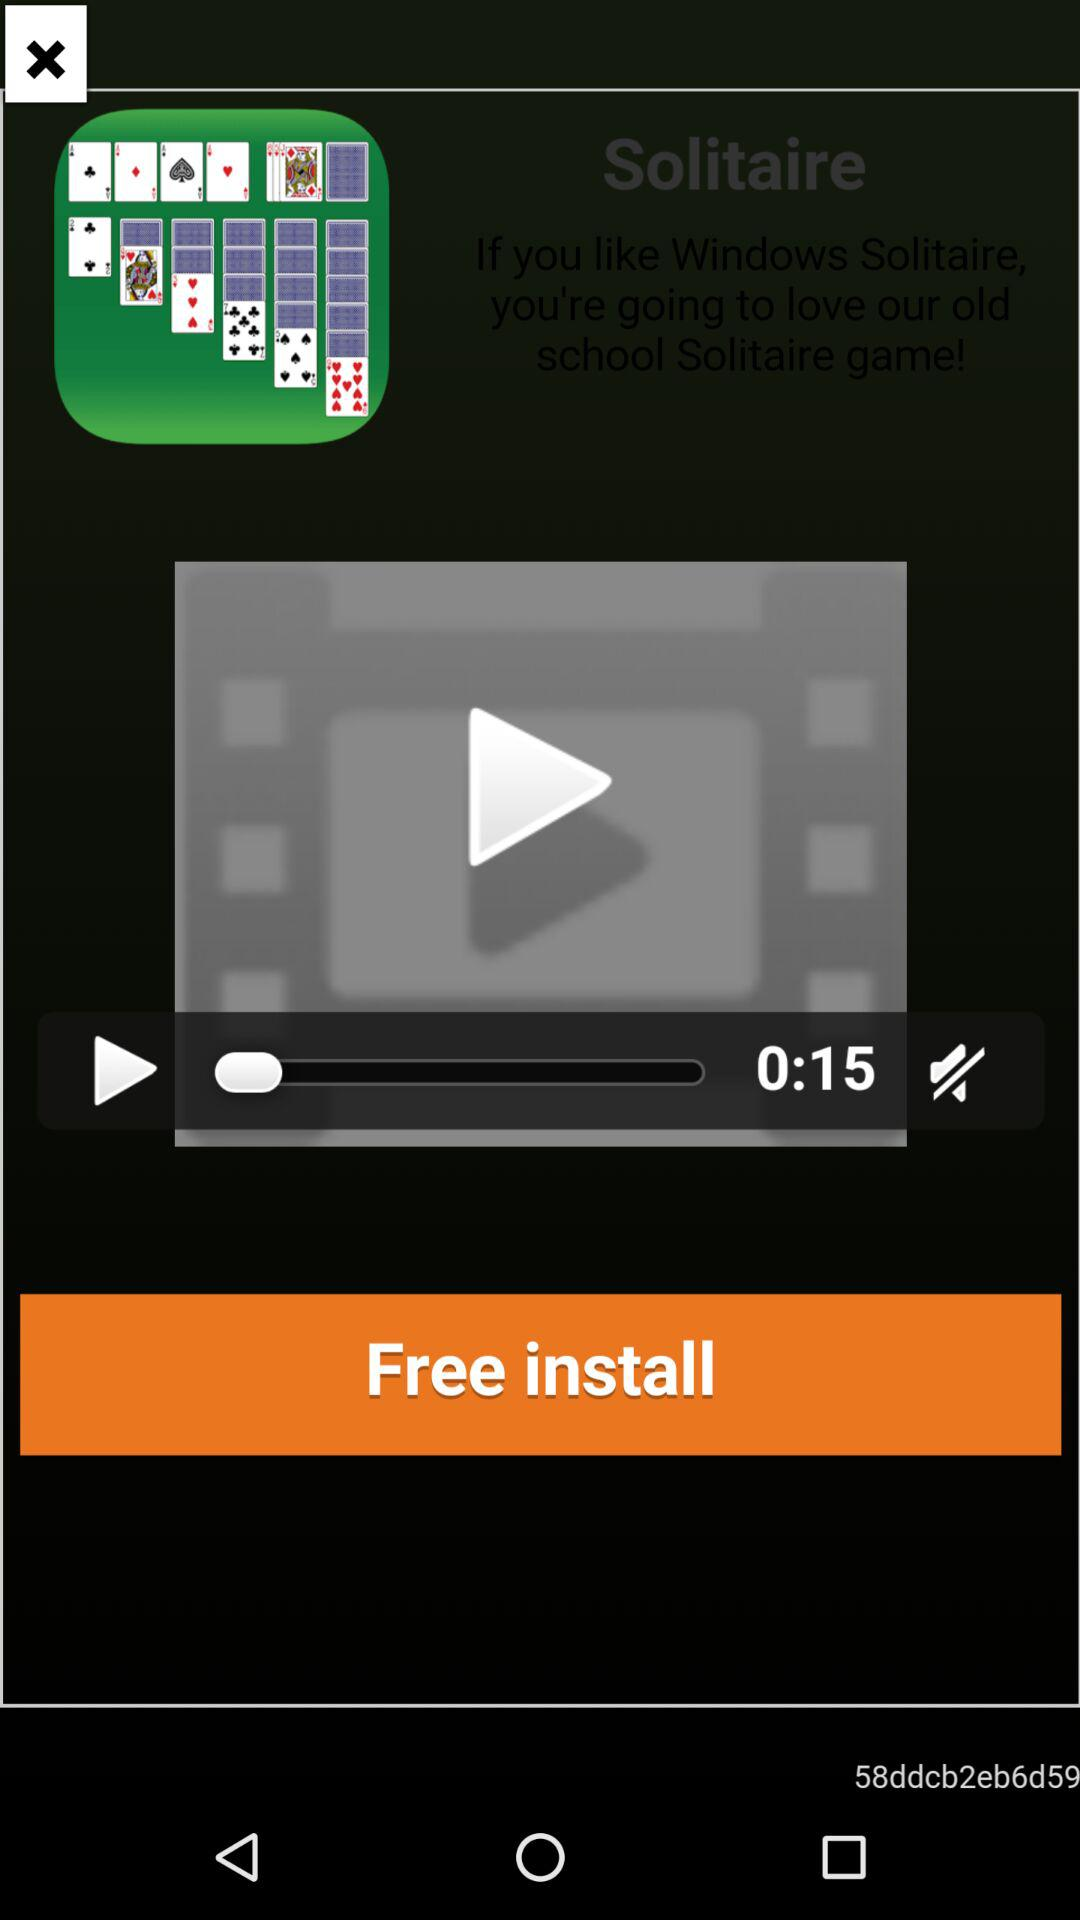What is the duration of the video? The duration of the video is 15 seconds. 